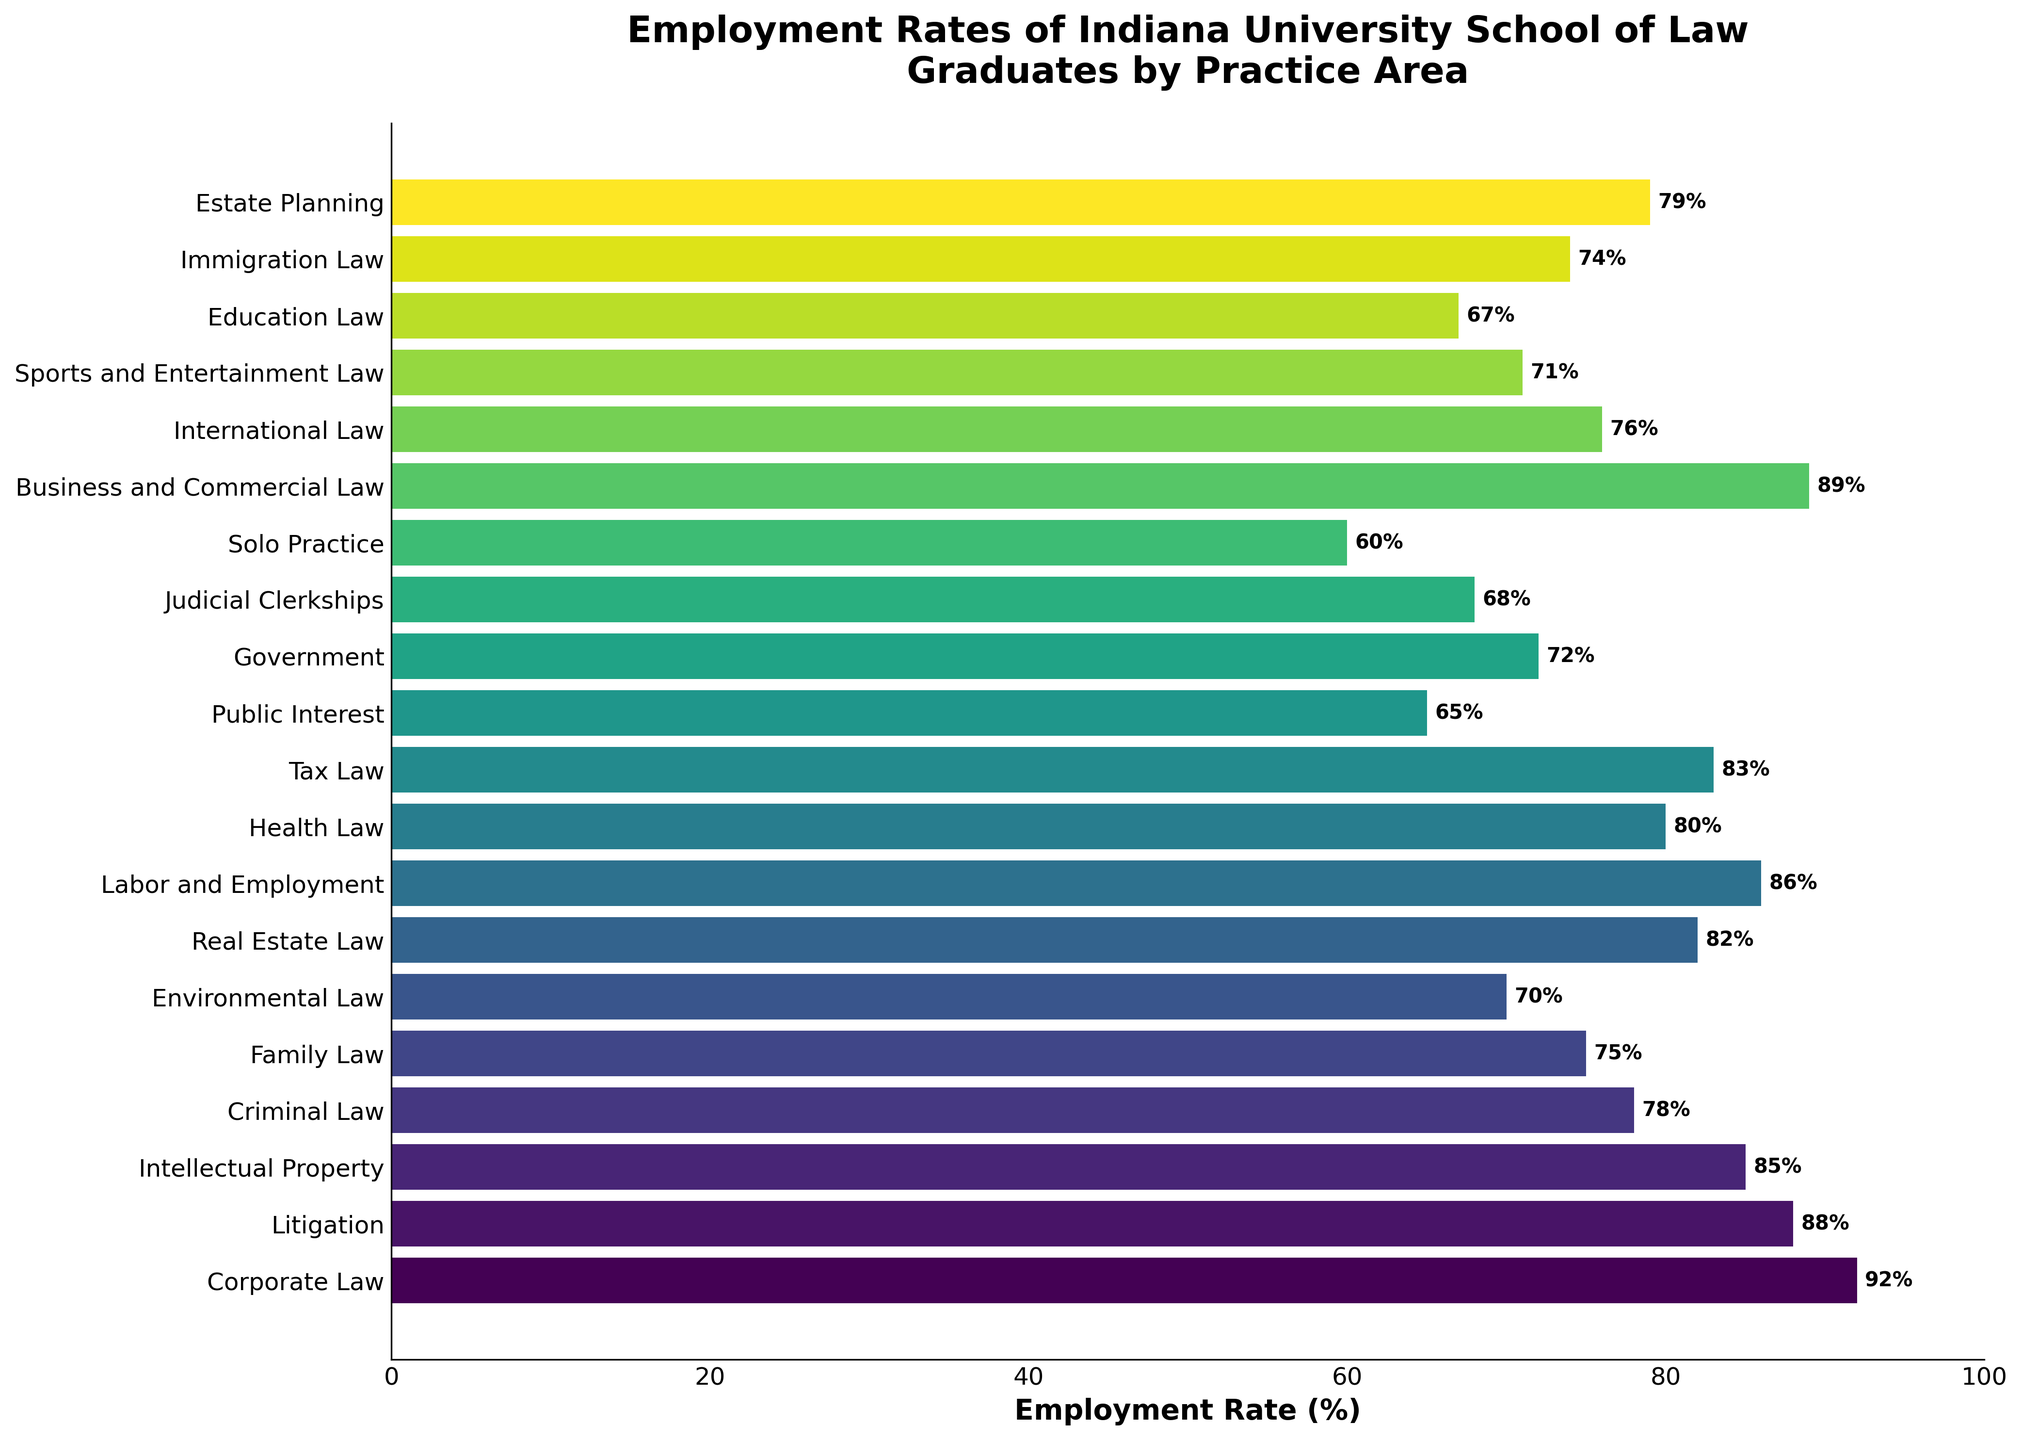Which practice area has the highest employment rate? The bar representing 'Corporate Law' extends the farthest to the right, surpassing all other bars, indicating that it has the highest employment rate.
Answer: Corporate Law Which two practice areas have employment rates closest to each other? The bars for 'Health Law' and 'Estate Planning' are very close to one another in length, with 'Health Law' at 80% and 'Estate Planning' at 79%, making them closest in employment rate.
Answer: Health Law and Estate Planning What's the average employment rate for Family Law, Corporate Law, and Litigation? To calculate the average, sum the employment rates of 'Family Law' (75%), 'Corporate Law' (92%), and 'Litigation' (88%), giving 255. Then divide by 3.
Answer: 85% Which practice area has the second lowest employment rate? After identifying the lowest employment rate 'Solo Practice' (60%), the next lowest bar is for 'Public Interest' at 65%.
Answer: Public Interest Which practice areas have employment rates higher than 85%? The bars that extend past the 85% mark are for 'Corporate Law' (92%), 'Business and Commercial Law' (89%), and 'Litigation' (88%), indicating they all have employment rates higher than 85%.
Answer: Corporate Law, Business and Commercial Law, Litigation How does the employment rate for Real Estate Law compare to the rate for Tax Law? The length of the bar for 'Real Estate Law' (82%) is slightly shorter than that for 'Tax Law' (83%). This means Real Estate Law's employment is 1% less than Tax Law's.
Answer: Real Estate Law is 1% less than Tax Law Which practice areas have employment rates between 70% and 75%? The bars for 'Family Law' (75%), 'International Law' (76%), 'Sports and Entertainment Law' (71%), 'Immigration Law' (74%), and 'Government' (72%) fall within this range.
Answer: Family Law, International Law, Sports and Entertainment Law, Immigration Law, Government What's the sum of employment rates for the fields with more than 80% employment? Adding up the employment rates of areas above 80%: 'Corporate Law' (92%), 'Litigation' (88%), 'Business and Commercial Law' (89%), 'Labor and Employment' (86%), 'Intellectual Property' (85%), 'Tax Law' (83%), 'Real Estate Law' (82%). Their sum: 92 + 88 + 89 + 86 + 85 + 83 + 82 = 605.
Answer: 605% What's the median employment rate for all practice areas? First, sort employment rates: 60, 65, 67, 68, 70, 71, 72, 74, 75, 76, 78, 79, 80, 82, 83, 85, 86, 88, 89, 92. With 20 values, the median is the average of the 10th and 11th values: (76 + 78) / 2 = 77.
Answer: 77% 